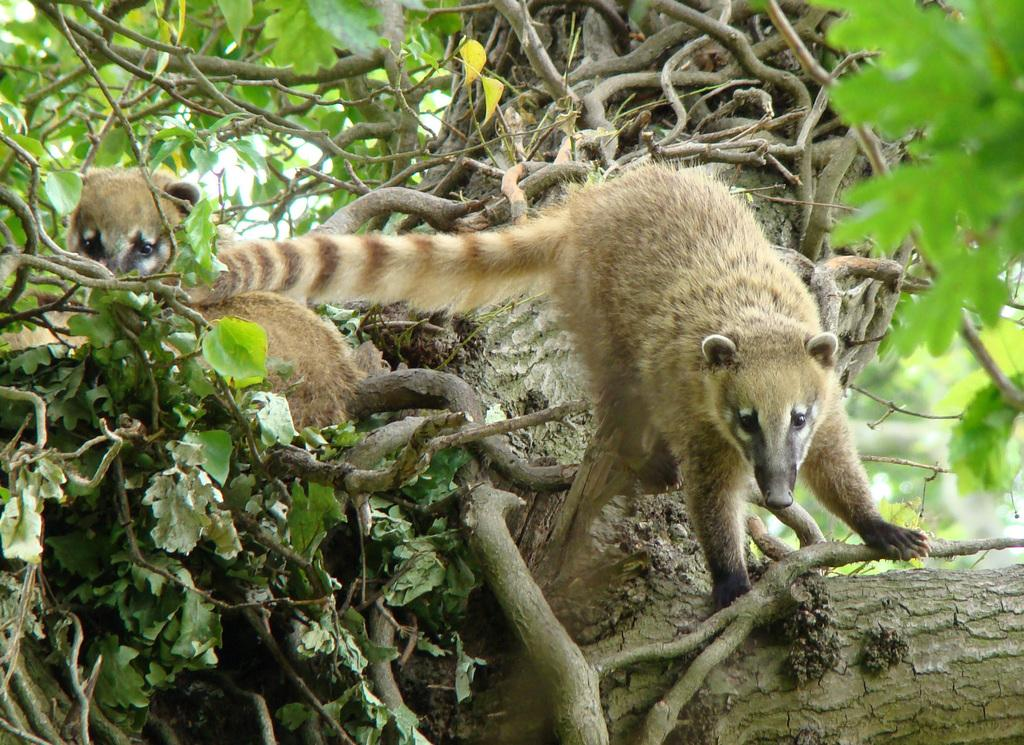What types of living organisms are present in the image? There are animals in the image. What else can be seen in the image besides the animals? There are stems, leaves, and branches in the image. What is the title of the book that the animals are reading in the image? There is no book or reading activity depicted in the image. 